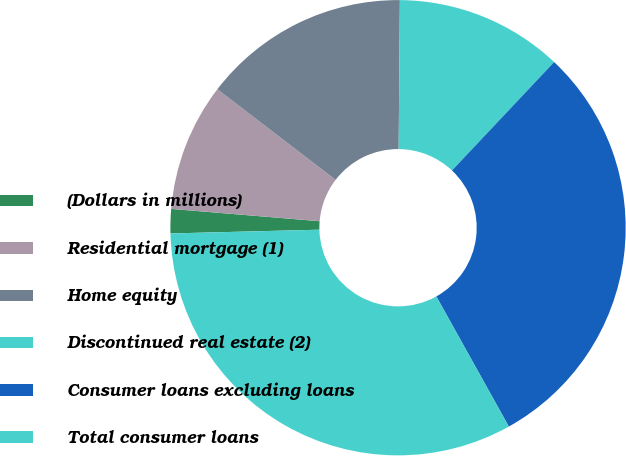<chart> <loc_0><loc_0><loc_500><loc_500><pie_chart><fcel>(Dollars in millions)<fcel>Residential mortgage (1)<fcel>Home equity<fcel>Discontinued real estate (2)<fcel>Consumer loans excluding loans<fcel>Total consumer loans<nl><fcel>1.72%<fcel>9.09%<fcel>14.72%<fcel>11.9%<fcel>29.88%<fcel>32.69%<nl></chart> 